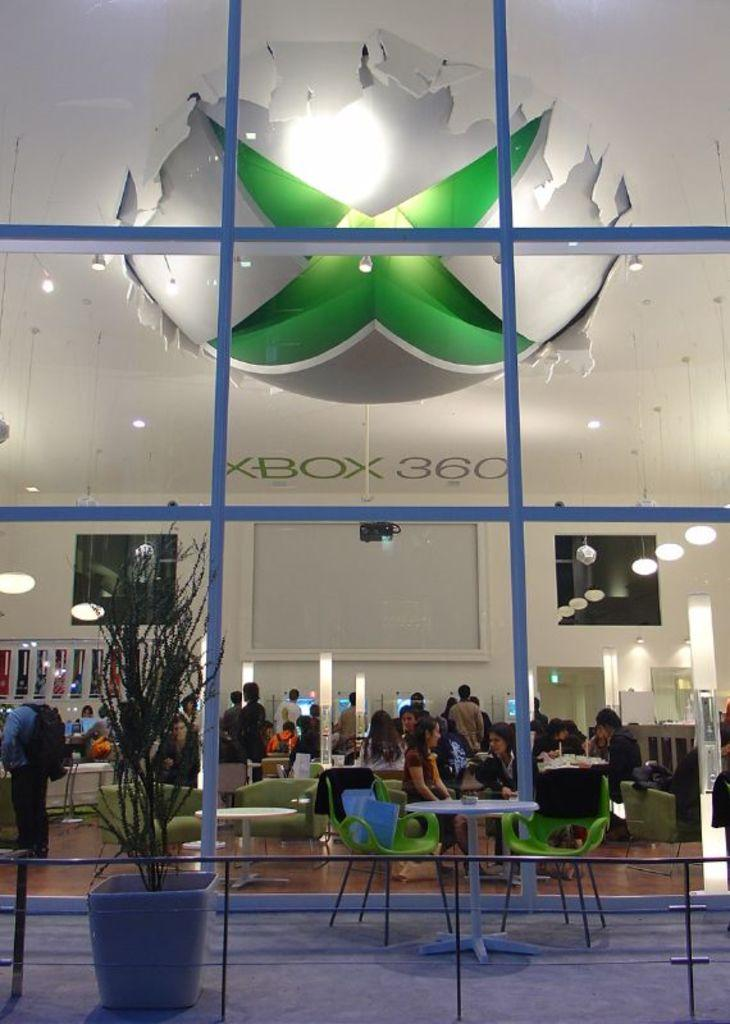What is the main subject of the image? The main subject of the image is a group of people. What are some of the people in the image doing? Some people are sitting on chairs, while others are standing. What can be seen in the background or surrounding the people? There are lights visible in the image, and there is a flower pot present. What type of meat is being served to the judge by the ladybug in the image? There is no judge, ladybug, or meat present in the image. 